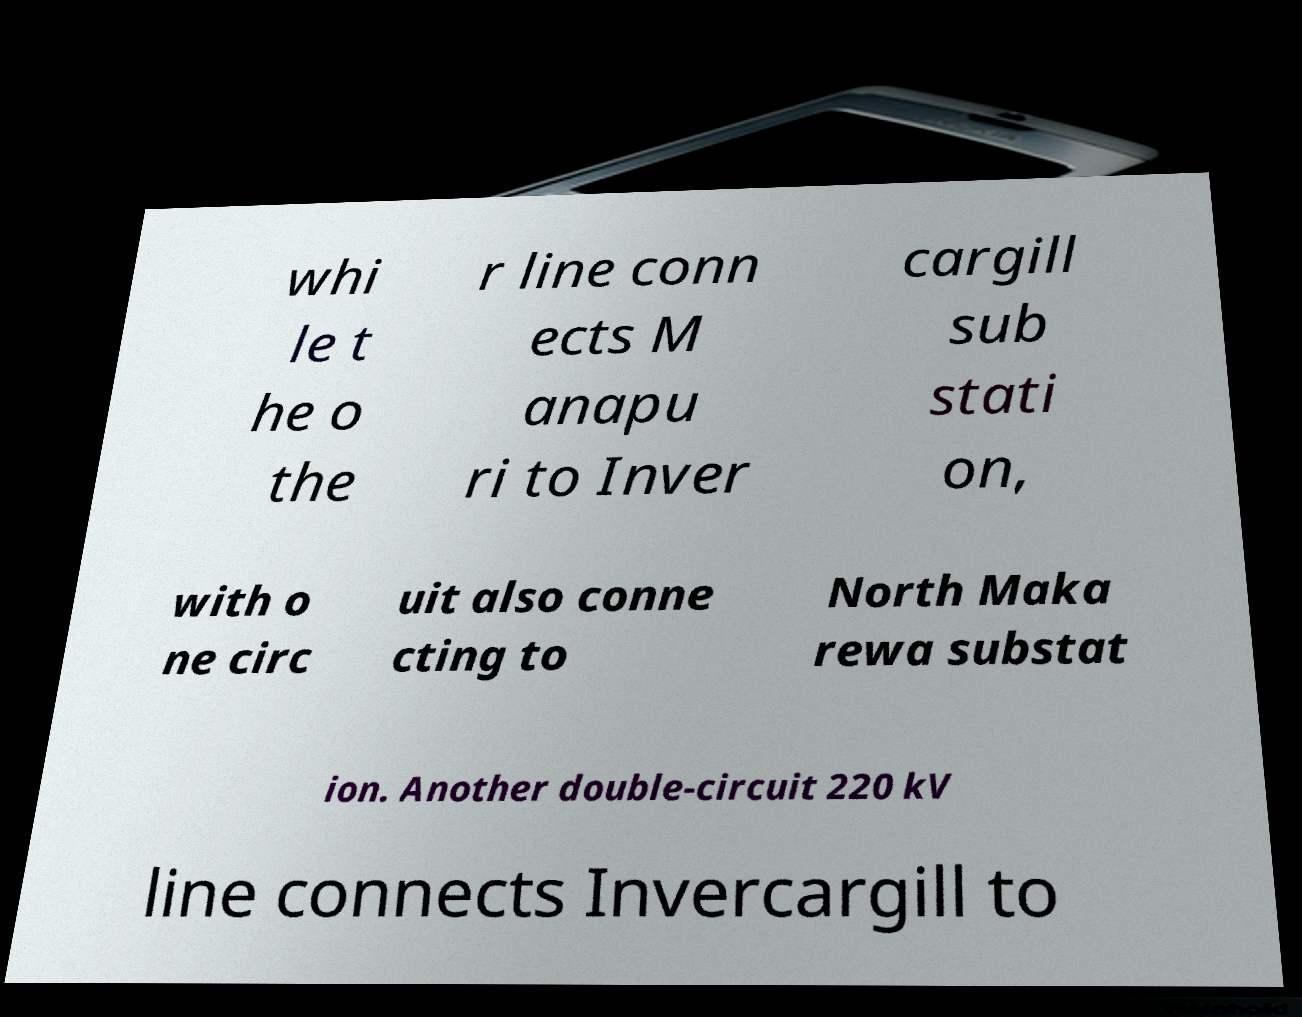For documentation purposes, I need the text within this image transcribed. Could you provide that? whi le t he o the r line conn ects M anapu ri to Inver cargill sub stati on, with o ne circ uit also conne cting to North Maka rewa substat ion. Another double-circuit 220 kV line connects Invercargill to 